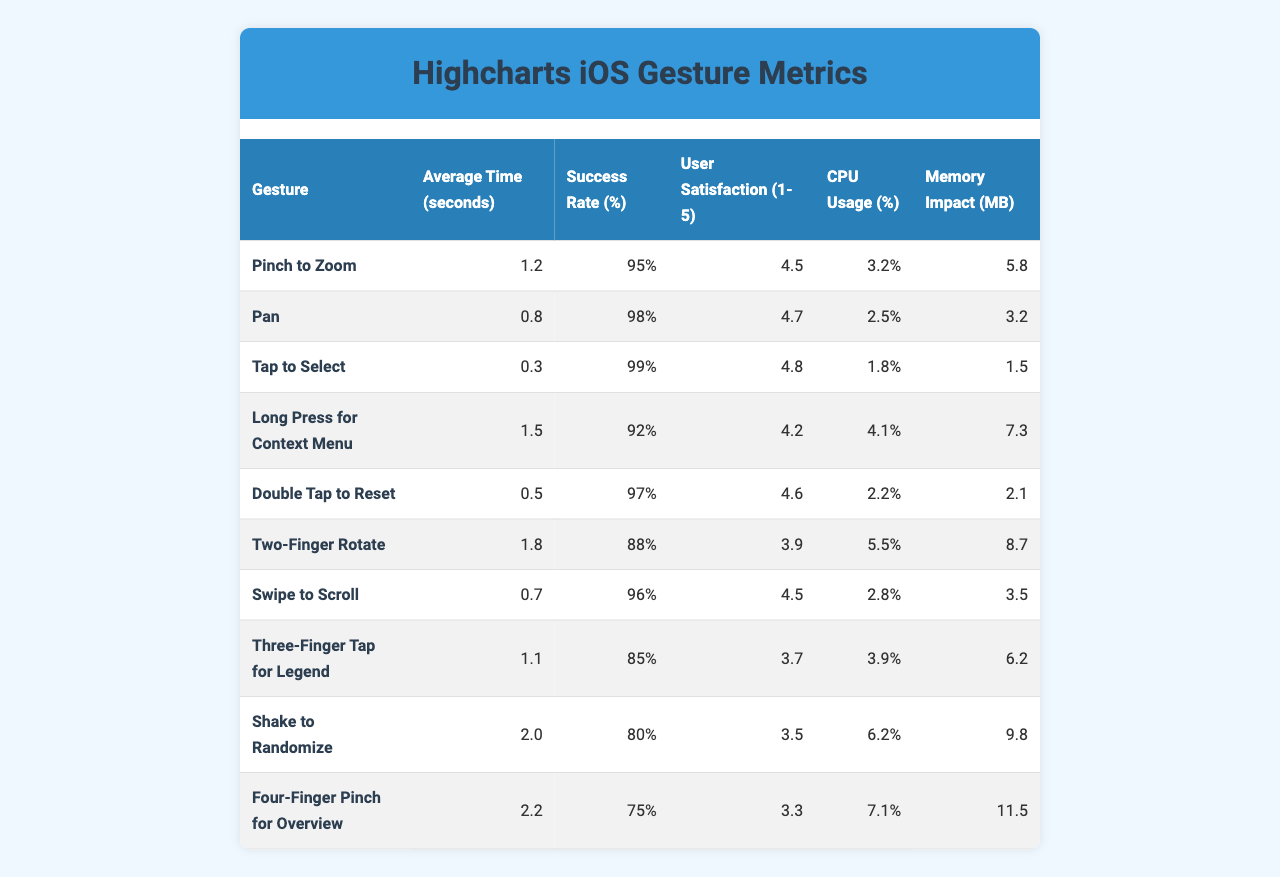What's the success rate of the "Tap to Select" gesture? The success rate is directly listed in the table under the "Success Rate (%)" column for the "Tap to Select" row, which shows 99%.
Answer: 99% Which gesture has the highest average time taken? By examining the "Average Time (seconds)" column, the row for "Four-Finger Pinch for Overview" shows the highest value of 2.2 seconds.
Answer: 2.2 seconds What is the average user satisfaction rating for all gestures? To find the average user satisfaction, add all the satisfaction ratings (4.5 + 4.7 + 4.8 + 4.2 + 4.6 + 3.9 + 4.5 + 3.7 + 3.5 + 3.3 = 46.7) and divide by the number of gestures (10), resulting in 46.7 / 10 = 4.67.
Answer: 4.67 Is the "Shake to Randomize" gesture more CPU-intensive than "Pinch to Zoom"? Compare the CPU usage values: "Shake to Randomize" has 6.2% while "Pinch to Zoom" has 3.2%. Since 6.2% is greater than 3.2%, "Shake to Randomize" is more CPU-intensive.
Answer: Yes Which gesture has the lowest memory impact and what is that value? By looking at the "Memory Impact (MB)" column, the "Tap to Select" gesture has the lowest value at 1.5 MB.
Answer: 1.5 MB How many gestures have a success rate above 90%? Count each gesture’s success rate from the "Success Rate (%)" column: "Pinch to Zoom" (95%), "Pan" (98%), "Tap to Select" (99%), "Double Tap to Reset" (97%), and "Long Press for Context Menu" (92%). This totals 5 gestures.
Answer: 5 What is the difference in average time between "Two-Finger Rotate" and "Swipe to Scroll"? The average time for "Two-Finger Rotate" is 1.8 seconds and for "Swipe to Scroll" is 0.7 seconds. The difference is 1.8 - 0.7 = 1.1 seconds.
Answer: 1.1 seconds Are more gestures rated with a user satisfaction of 4.5 or higher compared to those below 4.5? Evaluating the table, the following gestures have ratings of 4.5 or higher: "Pinch to Zoom," "Pan," "Tap to Select," "Double Tap to Reset," and "Swipe to Scroll," totaling 5. Those below 4.5 are "Long Press for Context Menu," "Two-Finger Rotate," "Three-Finger Tap for Legend," "Shake to Randomize," and "Four-Finger Pinch for Overview," totaling 5 as well. So, they are equal.
Answer: No Which gesture has the lowest success rate and how does it compare to the highest? The lowest success rate is for "Four-Finger Pinch for Overview" at 75%, and the highest is for "Tap to Select" at 99%. Comparing these reveals a difference of 99% - 75% = 24%.
Answer: 24% difference What gestures have a user satisfaction rating of 4.0 or below? From the data, both "Two-Finger Rotate" (3.9) and "Shake to Randomize" (3.5) have ratings of 4.0 or lower. Thus, these are the only two gestures fitting this criterion.
Answer: 2 gestures 